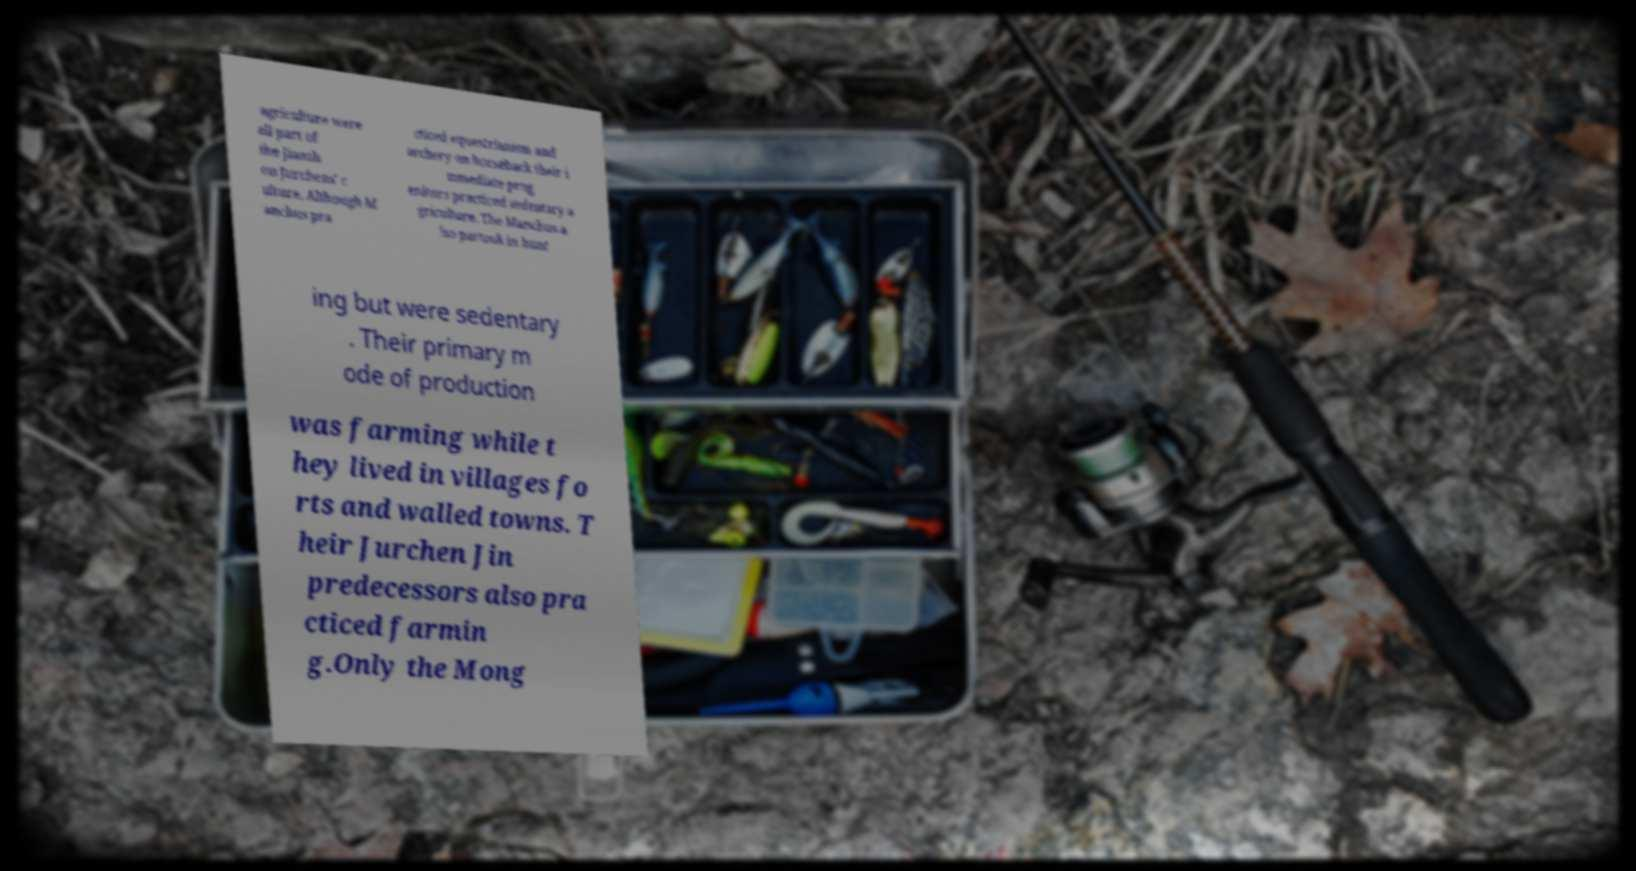What messages or text are displayed in this image? I need them in a readable, typed format. agriculture were all part of the Jianzh ou Jurchens' c ulture. Although M anchus pra cticed equestrianism and archery on horseback their i mmediate prog enitors practiced sedentary a griculture. The Manchus a lso partook in hunt ing but were sedentary . Their primary m ode of production was farming while t hey lived in villages fo rts and walled towns. T heir Jurchen Jin predecessors also pra cticed farmin g.Only the Mong 